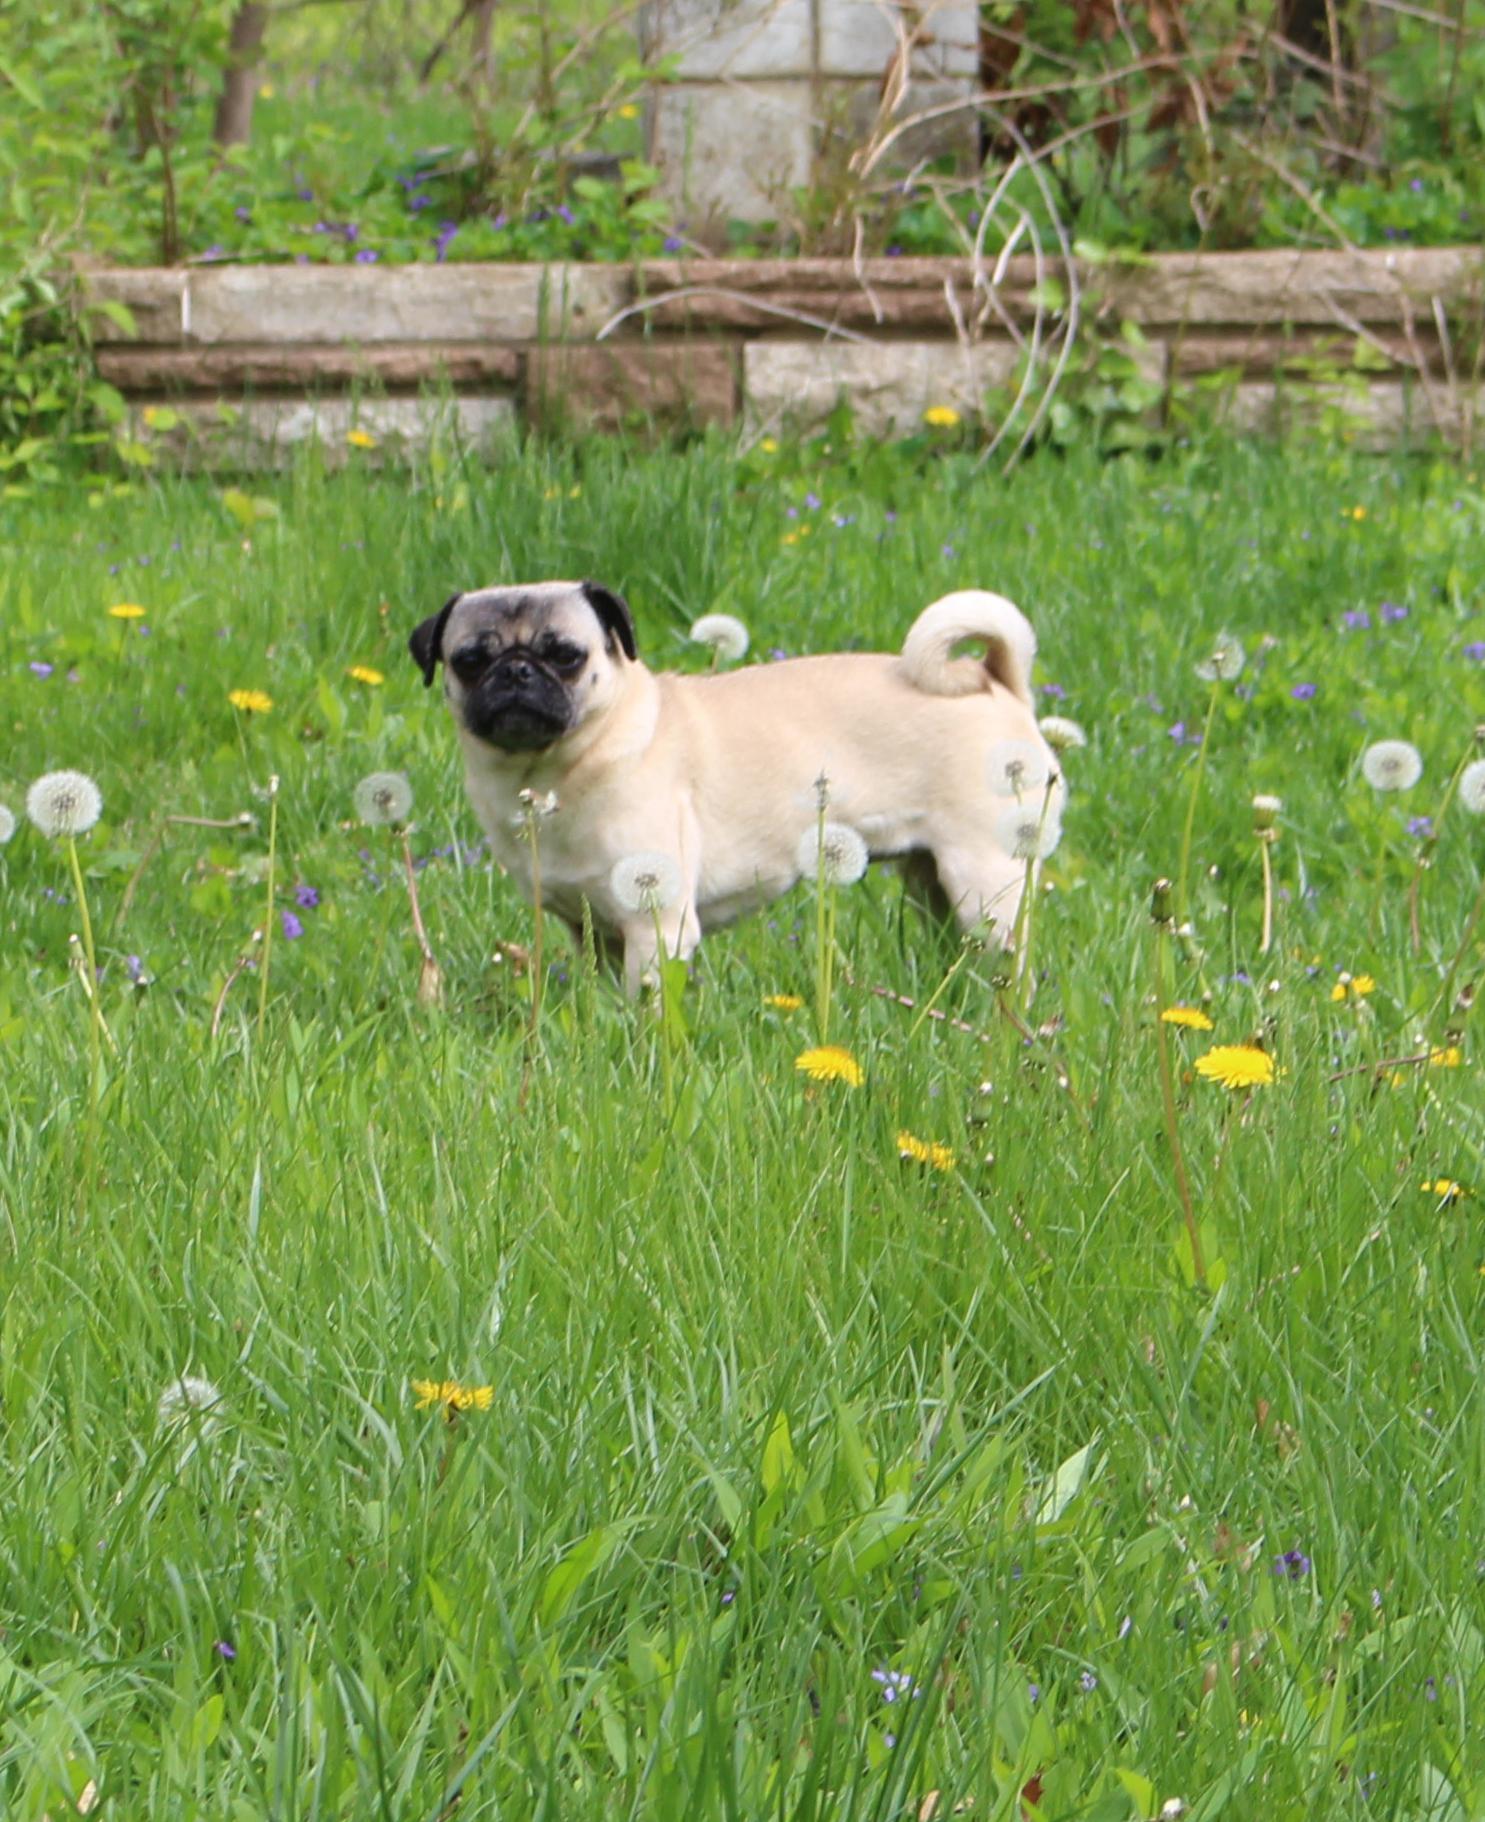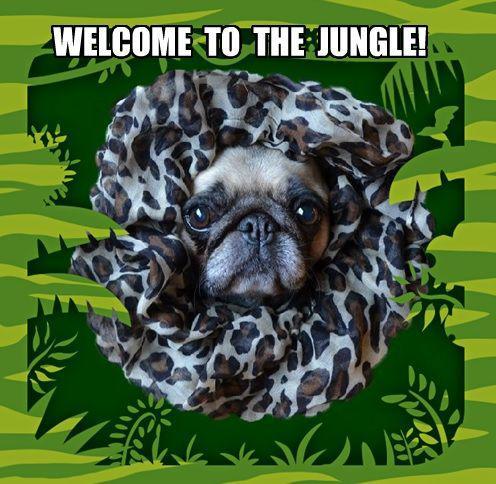The first image is the image on the left, the second image is the image on the right. Given the left and right images, does the statement "Each image includes one beige pug with a dark muzzle, who is surrounded by some type of green foliage." hold true? Answer yes or no. Yes. The first image is the image on the left, the second image is the image on the right. Examine the images to the left and right. Is the description "I at least one image there is a pug looking straight forward wearing a costume that circles its head." accurate? Answer yes or no. Yes. 